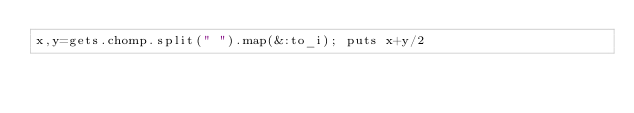Convert code to text. <code><loc_0><loc_0><loc_500><loc_500><_Ruby_>x,y=gets.chomp.split(" ").map(&:to_i); puts x+y/2</code> 